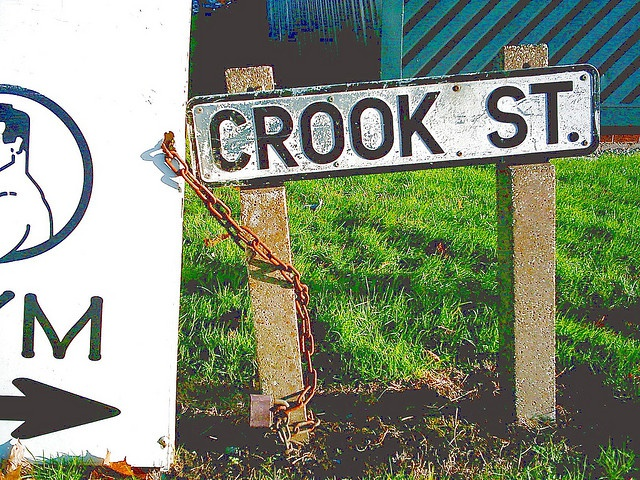Describe the objects in this image and their specific colors. I can see various objects in this image with different colors. 